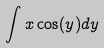Convert formula to latex. <formula><loc_0><loc_0><loc_500><loc_500>\int x \cos ( y ) d y</formula> 